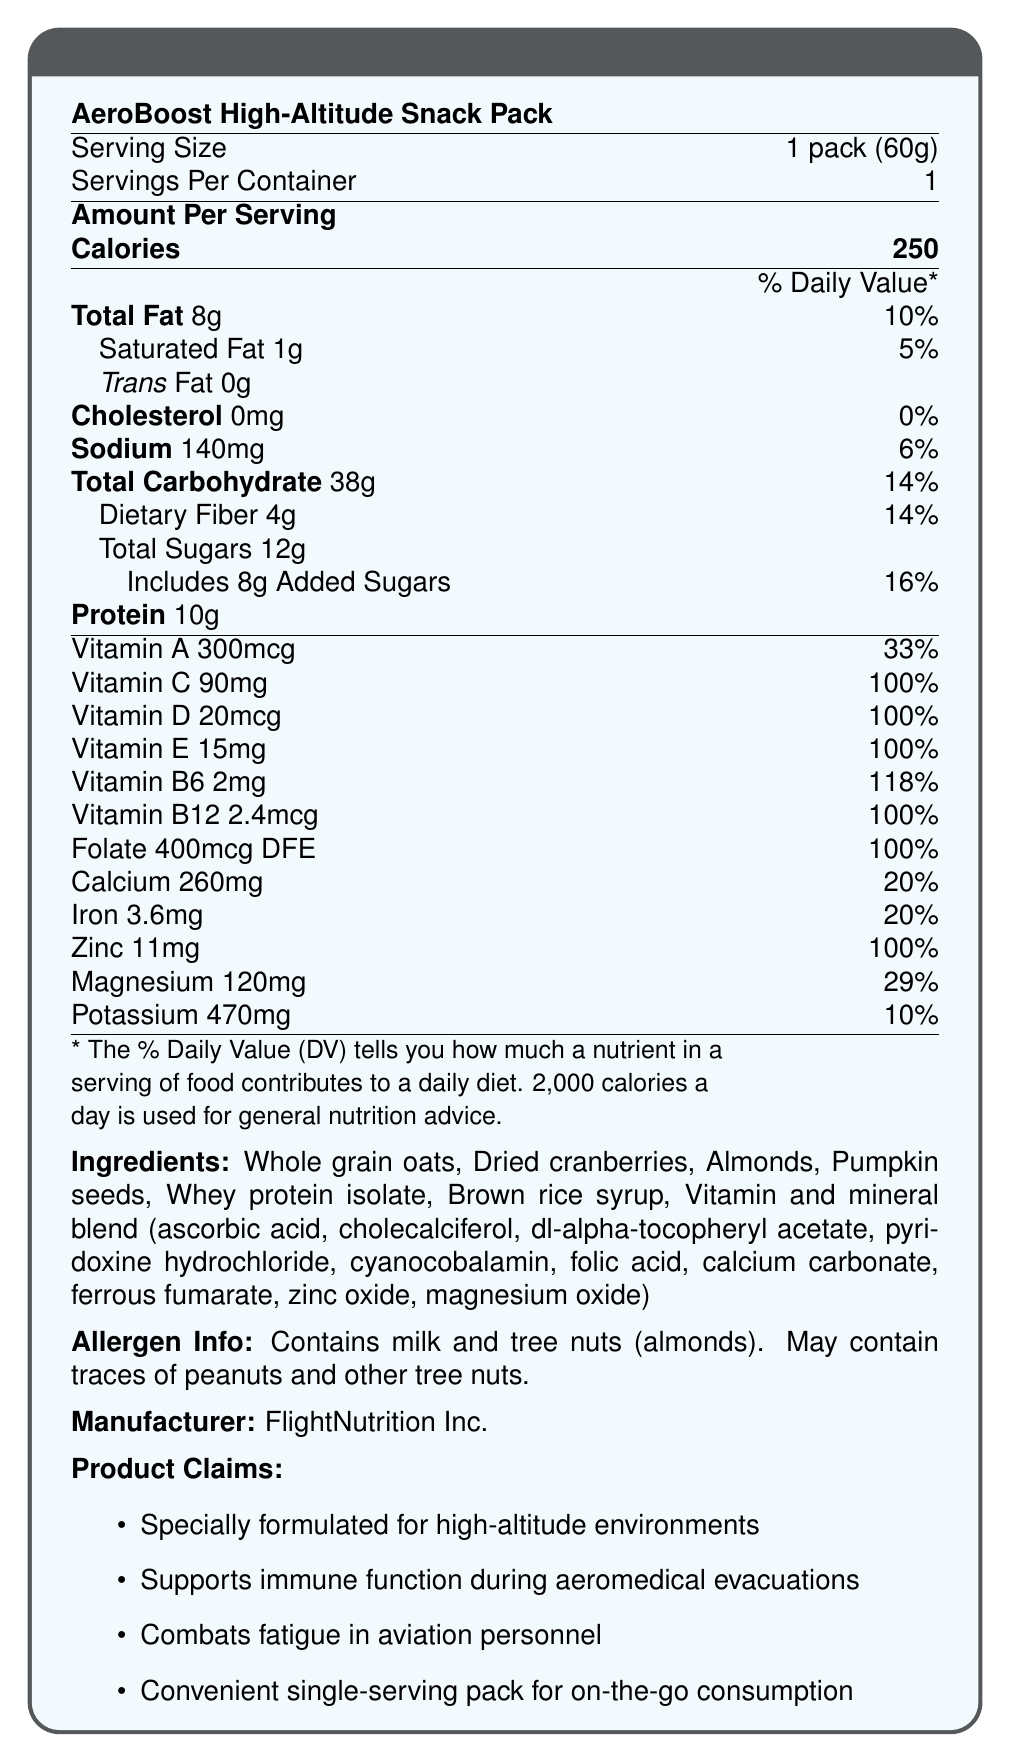What is the serving size of the AeroBoost High-Altitude Snack Pack? The document states that the serving size is 1 pack (60g).
Answer: 1 pack (60g) How many calories are in one serving? The document specifies that there are 250 calories per serving.
Answer: 250 What percentage of the daily value of Vitamin C does one serving provide? The document indicates that one serving provides 100% of the daily value of Vitamin C.
Answer: 100% What ingredients are mentioned in the AeroBoost High-Altitude Snack Pack? The ingredients list is provided towards the end of the document.
Answer: Whole grain oats, Dried cranberries, Almonds, Pumpkin seeds, Whey protein isolate, Brown rice syrup, Vitamin and mineral blend (ascorbic acid, cholecalciferol, dl-alpha-tocopheryl acetate, pyridoxine hydrochloride, cyanocobalamin, folic acid, calcium carbonate, ferrous fumarate, zinc oxide, magnesium oxide) How much sodium is in one pack? The nutrition facts indicate that one serving contains 140mg of sodium.
Answer: 140mg How many grams of dietary fiber are in a serving? The document notes that a serving contains 4g of dietary fiber.
Answer: 4g What company manufactures the AeroBoost High-Altitude Snack Pack? The document specifies that the manufacturer is FlightNutrition Inc.
Answer: FlightNutrition Inc. What is the Vitamin B6 daily value percentage provided by one serving? The document mentions that one serving provides 118% of the daily value for Vitamin B6.
Answer: 118% Which of the following vitamins are present in this snack pack at 100% of the daily value? A. Vitamin A B. Vitamin C C. Vitamin E D. All of the above The document shows that Vitamin C, Vitamin D, Vitamin E, Vitamin B12, and Folate are provided at 100%, but not Vitamin A.
Answer: B and C What percentage of the daily value of iron does a serving of this snack pack provide? The nutrition facts label indicates that one serving provides 20% of the daily value for iron.
Answer: 20% Is this snack pack free of trans fat? The document specifies that the trans fat content is 0g.
Answer: Yes True or False: The snack pack includes peanut ingredients. According to the allergen information, it contains milk and tree nuts (almonds) and may contain traces of peanuts, but does not list peanuts as an ingredient.
Answer: False Summarize the main purpose of the AeroBoost High-Altitude Snack Pack based on the product claims. The product claims section of the document indicates that the snack pack is designed to support immune function, combat fatigue, and is easy to carry and consume.
Answer: The AeroBoost High-Altitude Snack Pack is specially formulated for high-altitude environments to support immune function during aeromedical evacuations and combat fatigue in aviation personnel. It comes in a convenient single-serving pack for on-the-go consumption. What is the amount of total sugars in one serving? The document specifies that the total sugar content in one serving is 12g.
Answer: 12g What is the daily value percentage of magnesium provided by the snack pack? The document states that one serving of the snack pack provides 29% of the daily value for magnesium.
Answer: 29% How many servings are in one container? The document indicates that there is 1 serving per container.
Answer: 1 What is the price of the AeroBoost High-Altitude Snack Pack? The document does not mention the price of the snack pack.
Answer: Cannot be determined Which of the following is NOT an ingredient in the snack pack? A. Whole grain oats B. Almonds C. Dark chocolate D. Pumpkin seeds The list of ingredients does not include dark chocolate.
Answer: C 